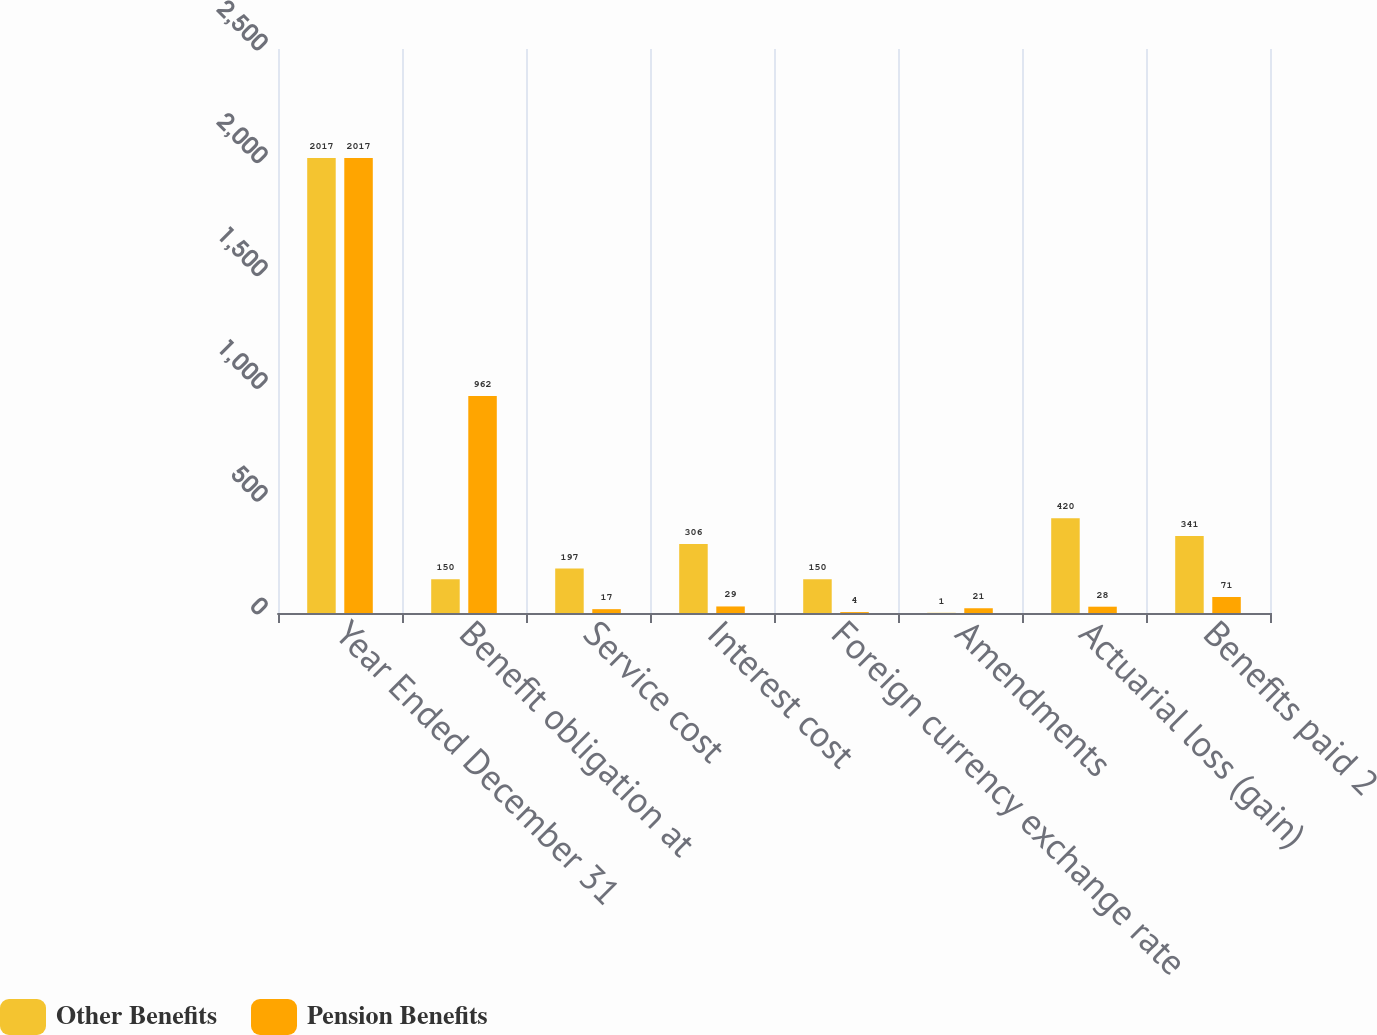Convert chart. <chart><loc_0><loc_0><loc_500><loc_500><stacked_bar_chart><ecel><fcel>Year Ended December 31<fcel>Benefit obligation at<fcel>Service cost<fcel>Interest cost<fcel>Foreign currency exchange rate<fcel>Amendments<fcel>Actuarial loss (gain)<fcel>Benefits paid 2<nl><fcel>Other Benefits<fcel>2017<fcel>150<fcel>197<fcel>306<fcel>150<fcel>1<fcel>420<fcel>341<nl><fcel>Pension Benefits<fcel>2017<fcel>962<fcel>17<fcel>29<fcel>4<fcel>21<fcel>28<fcel>71<nl></chart> 